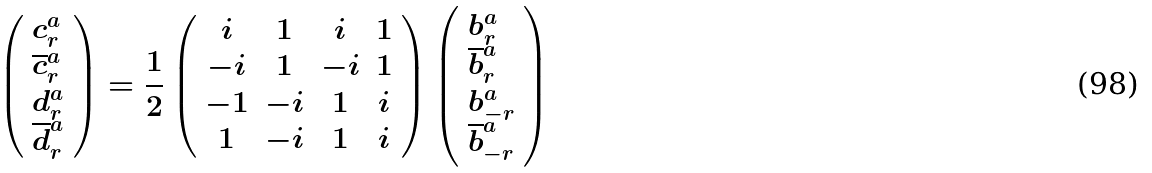Convert formula to latex. <formula><loc_0><loc_0><loc_500><loc_500>\left ( \begin{array} { l } c _ { r } ^ { a } \\ \overline { c } _ { r } ^ { a } \\ d _ { r } ^ { a } \\ \overline { d } _ { r } ^ { a } \end{array} \right ) = \frac { 1 } { 2 } \left ( \begin{array} { c c c c } i & 1 & i & 1 \\ - i & 1 & - i & 1 \\ - 1 & - i & 1 & i \\ 1 & - i & 1 & i \end{array} \right ) \left ( \begin{array} { l } b _ { r } ^ { a } \\ \overline { b } _ { r } ^ { a } \\ b _ { - r } ^ { a } \\ \overline { b } _ { - r } ^ { a } \end{array} \right )</formula> 